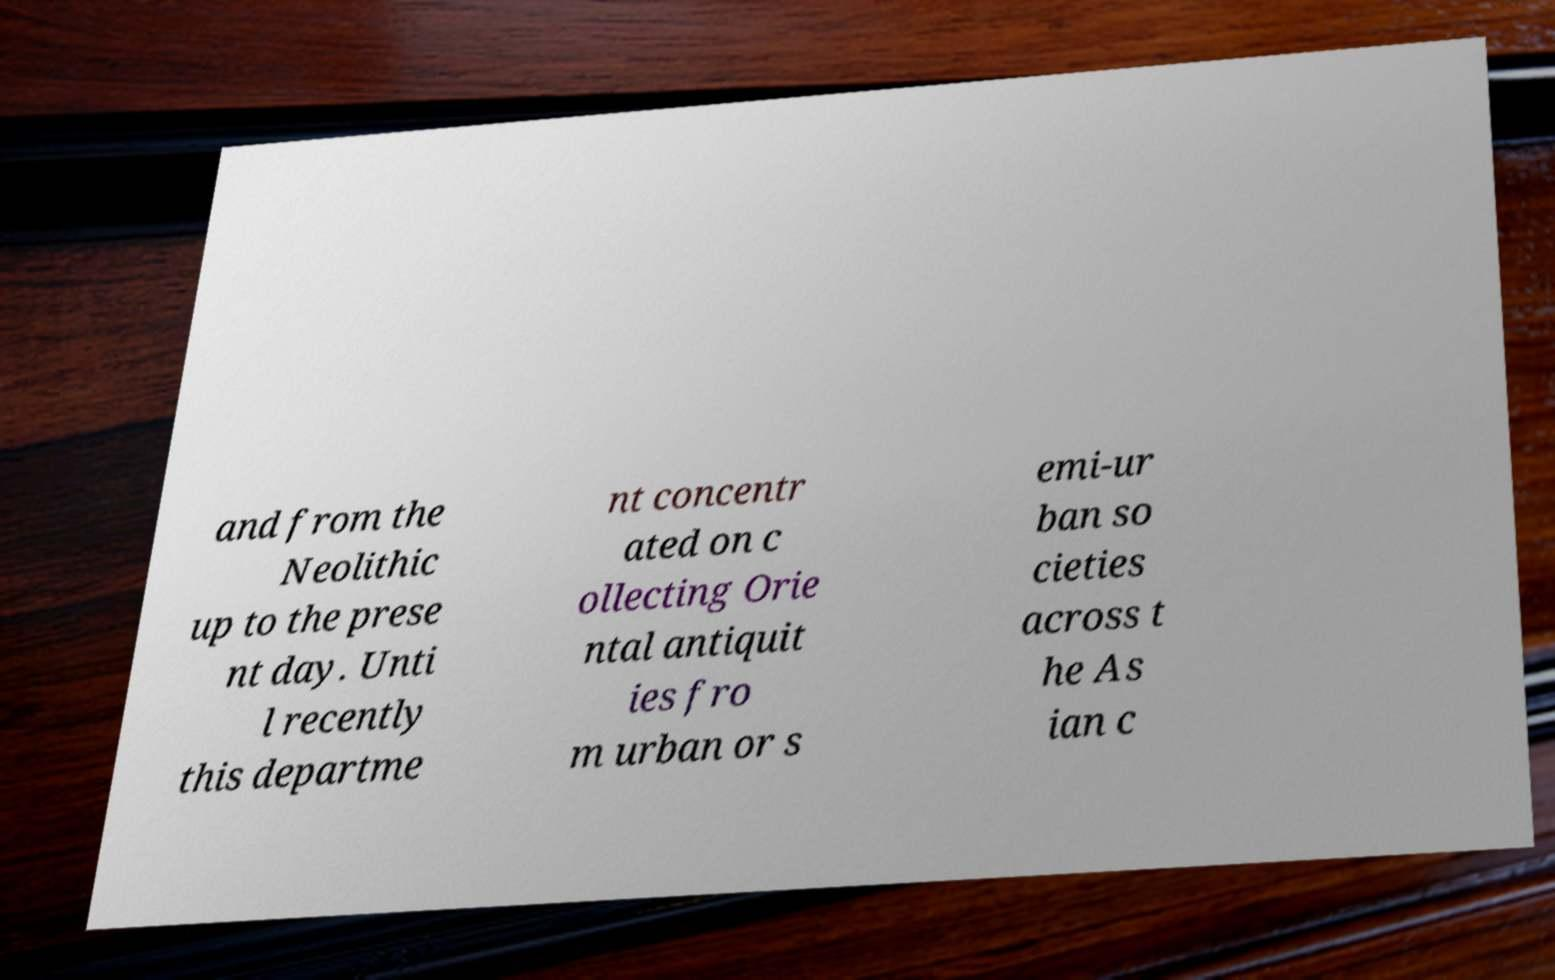What messages or text are displayed in this image? I need them in a readable, typed format. and from the Neolithic up to the prese nt day. Unti l recently this departme nt concentr ated on c ollecting Orie ntal antiquit ies fro m urban or s emi-ur ban so cieties across t he As ian c 